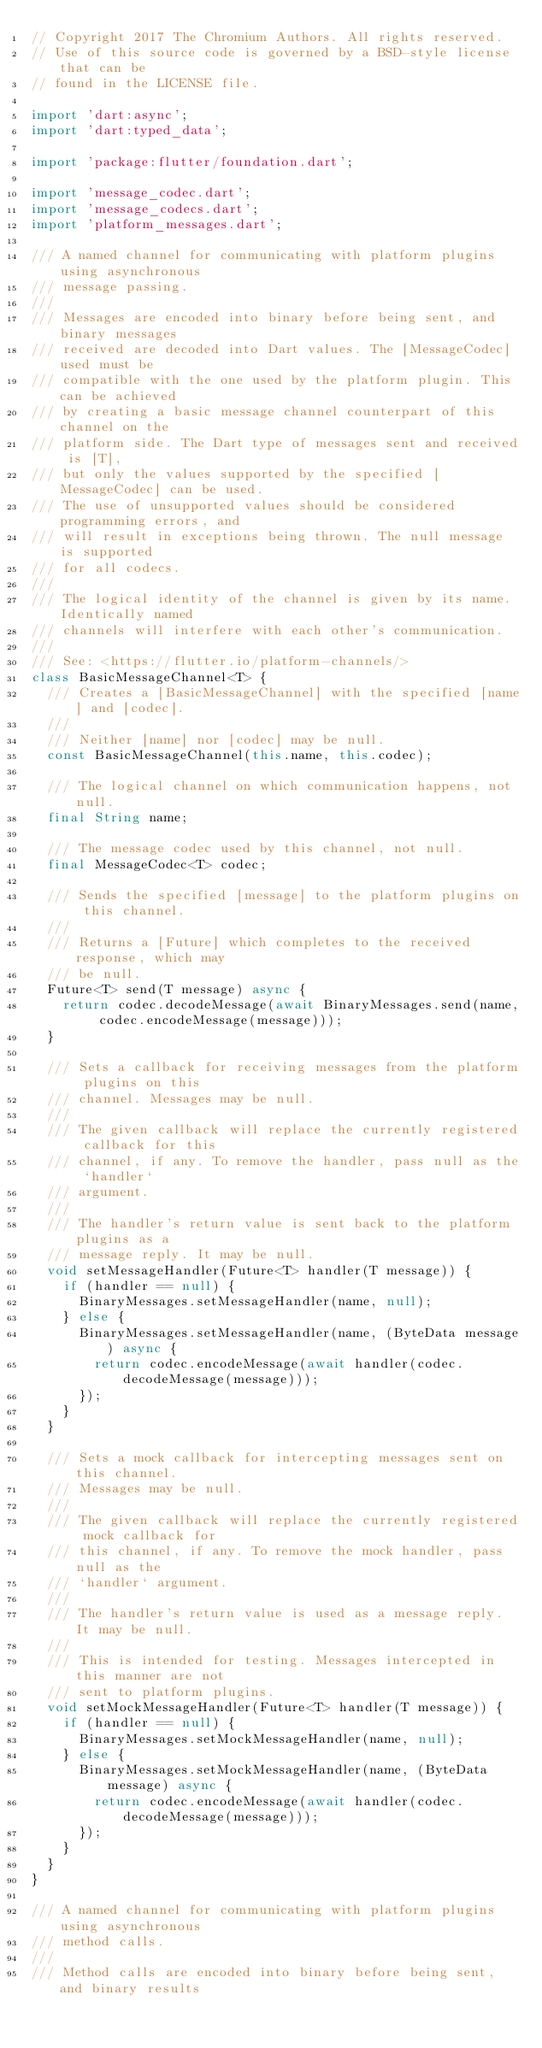<code> <loc_0><loc_0><loc_500><loc_500><_Dart_>// Copyright 2017 The Chromium Authors. All rights reserved.
// Use of this source code is governed by a BSD-style license that can be
// found in the LICENSE file.

import 'dart:async';
import 'dart:typed_data';

import 'package:flutter/foundation.dart';

import 'message_codec.dart';
import 'message_codecs.dart';
import 'platform_messages.dart';

/// A named channel for communicating with platform plugins using asynchronous
/// message passing.
///
/// Messages are encoded into binary before being sent, and binary messages
/// received are decoded into Dart values. The [MessageCodec] used must be
/// compatible with the one used by the platform plugin. This can be achieved
/// by creating a basic message channel counterpart of this channel on the
/// platform side. The Dart type of messages sent and received is [T],
/// but only the values supported by the specified [MessageCodec] can be used.
/// The use of unsupported values should be considered programming errors, and
/// will result in exceptions being thrown. The null message is supported
/// for all codecs.
///
/// The logical identity of the channel is given by its name. Identically named
/// channels will interfere with each other's communication.
///
/// See: <https://flutter.io/platform-channels/>
class BasicMessageChannel<T> {
  /// Creates a [BasicMessageChannel] with the specified [name] and [codec].
  ///
  /// Neither [name] nor [codec] may be null.
  const BasicMessageChannel(this.name, this.codec);

  /// The logical channel on which communication happens, not null.
  final String name;

  /// The message codec used by this channel, not null.
  final MessageCodec<T> codec;

  /// Sends the specified [message] to the platform plugins on this channel.
  ///
  /// Returns a [Future] which completes to the received response, which may
  /// be null.
  Future<T> send(T message) async {
    return codec.decodeMessage(await BinaryMessages.send(name, codec.encodeMessage(message)));
  }

  /// Sets a callback for receiving messages from the platform plugins on this
  /// channel. Messages may be null.
  ///
  /// The given callback will replace the currently registered callback for this
  /// channel, if any. To remove the handler, pass null as the `handler`
  /// argument.
  ///
  /// The handler's return value is sent back to the platform plugins as a
  /// message reply. It may be null.
  void setMessageHandler(Future<T> handler(T message)) {
    if (handler == null) {
      BinaryMessages.setMessageHandler(name, null);
    } else {
      BinaryMessages.setMessageHandler(name, (ByteData message) async {
        return codec.encodeMessage(await handler(codec.decodeMessage(message)));
      });
    }
  }

  /// Sets a mock callback for intercepting messages sent on this channel.
  /// Messages may be null.
  ///
  /// The given callback will replace the currently registered mock callback for
  /// this channel, if any. To remove the mock handler, pass null as the
  /// `handler` argument.
  ///
  /// The handler's return value is used as a message reply. It may be null.
  ///
  /// This is intended for testing. Messages intercepted in this manner are not
  /// sent to platform plugins.
  void setMockMessageHandler(Future<T> handler(T message)) {
    if (handler == null) {
      BinaryMessages.setMockMessageHandler(name, null);
    } else {
      BinaryMessages.setMockMessageHandler(name, (ByteData message) async {
        return codec.encodeMessage(await handler(codec.decodeMessage(message)));
      });
    }
  }
}

/// A named channel for communicating with platform plugins using asynchronous
/// method calls.
///
/// Method calls are encoded into binary before being sent, and binary results</code> 